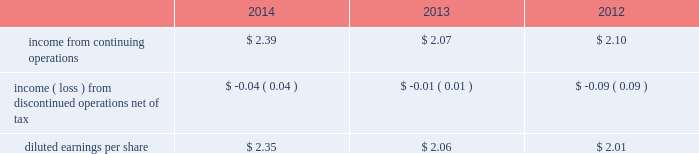From those currently anticipated and expressed in such forward-looking statements as a result of a number of factors , including those we discuss under 201crisk factors 201d and elsewhere in this form 10-k .
You should read 201crisk factors 201d and 201cforward-looking statements . 201d executive overview general american water works company , inc .
( herein referred to as 201camerican water 201d or the 201ccompany 201d ) is the largest investor-owned united states water and wastewater utility company , as measured both by operating revenues and population served .
Our approximately 6400 employees provide drinking water , wastewater and other water related services to an estimated 15 million people in 47 states and in one canadian province .
Our primary business involves the ownership of water and wastewater utilities that provide water and wastewater services to residential , commercial , industrial and other customers .
Our regulated businesses that provide these services are generally subject to economic regulation by state regulatory agencies in the states in which they operate .
The federal government and the states also regulate environmental , health and safety and water quality matters .
Our regulated businesses provide services in 16 states and serve approximately 3.2 million customers based on the number of active service connections to our water and wastewater networks .
We report the results of these businesses in our regulated businesses segment .
We also provide services that are not subject to economic regulation by state regulatory agencies .
We report the results of these businesses in our market-based operations segment .
In 2014 , we continued the execution of our strategic goals .
Our commitment to growth through investment in our regulated infrastructure and expansion of our regulated customer base and our market-based operations , combined with operational excellence led to continued improvement in regulated operating efficiency , improved performance of our market-based operations , and enabled us to provide increased value to our customers and investors .
During the year , we focused on growth , addressed regulatory lag , made more efficient use of capital and improved our regulated operation and maintenance ( 201co&m 201d ) efficiency ratio .
2014 financial results for the year ended december 31 , 2014 , we continued to increase net income , while making significant capital investment in our infrastructure and implementing operational efficiency improvements to keep customer rates affordable .
Highlights of our 2014 operating results compared to 2013 and 2012 include: .
Continuing operations income from continuing operations included 4 cents per diluted share of costs resulting from the freedom industries chemical spill in west virginia in 2014 and included 14 cents per diluted share in 2013 related to a tender offer .
Earnings from continuing operations , adjusted for these two items , increased 10% ( 10 % ) , or 22 cents per share , mainly due to favorable operating results from our regulated businesses segment due to higher revenues and lower operating expenses , partially offset by higher depreciation expenses .
Also contributing to the overall increase in income from continuing operations was lower interest expense in 2014 compared to the same period in 2013. .
In 2014 what was the income from continuing operations adjusted for diluting operations? 
Rationale: the income from continuing operations in 2014 was given as 2.39 while the dilute operations included from continuing operations was 0.04 thus the adjusted income less dilute operations was 2.35
Computations: (2.39 - 0.04)
Answer: 2.35. 